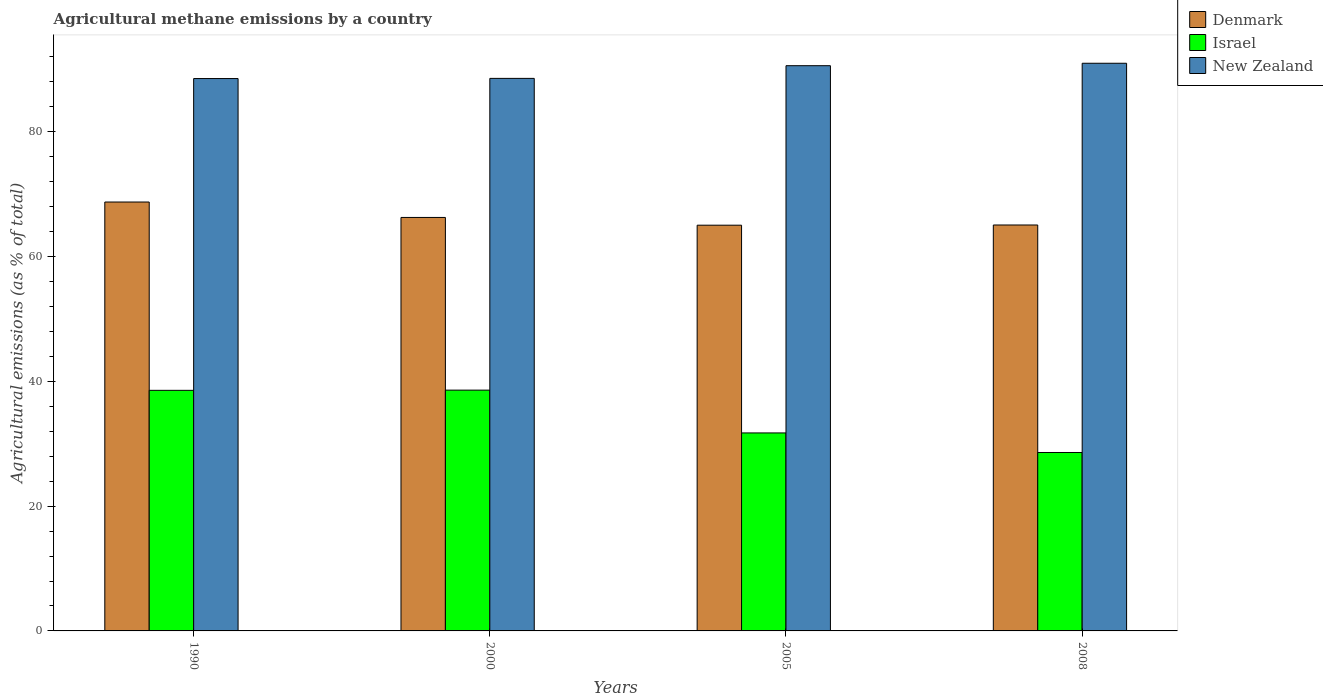How many different coloured bars are there?
Provide a short and direct response. 3. How many groups of bars are there?
Ensure brevity in your answer.  4. Are the number of bars on each tick of the X-axis equal?
Give a very brief answer. Yes. How many bars are there on the 4th tick from the left?
Ensure brevity in your answer.  3. What is the label of the 3rd group of bars from the left?
Ensure brevity in your answer.  2005. What is the amount of agricultural methane emitted in Israel in 2008?
Offer a terse response. 28.6. Across all years, what is the maximum amount of agricultural methane emitted in Israel?
Make the answer very short. 38.59. Across all years, what is the minimum amount of agricultural methane emitted in Denmark?
Ensure brevity in your answer.  65.03. In which year was the amount of agricultural methane emitted in New Zealand minimum?
Provide a short and direct response. 1990. What is the total amount of agricultural methane emitted in Denmark in the graph?
Offer a terse response. 265.11. What is the difference between the amount of agricultural methane emitted in Israel in 1990 and that in 2005?
Make the answer very short. 6.83. What is the difference between the amount of agricultural methane emitted in Denmark in 2008 and the amount of agricultural methane emitted in Israel in 1990?
Give a very brief answer. 26.5. What is the average amount of agricultural methane emitted in Israel per year?
Make the answer very short. 34.37. In the year 2005, what is the difference between the amount of agricultural methane emitted in Israel and amount of agricultural methane emitted in Denmark?
Give a very brief answer. -33.3. In how many years, is the amount of agricultural methane emitted in New Zealand greater than 52 %?
Provide a short and direct response. 4. What is the ratio of the amount of agricultural methane emitted in Israel in 2000 to that in 2008?
Give a very brief answer. 1.35. Is the amount of agricultural methane emitted in Denmark in 1990 less than that in 2000?
Your answer should be compact. No. Is the difference between the amount of agricultural methane emitted in Israel in 2000 and 2008 greater than the difference between the amount of agricultural methane emitted in Denmark in 2000 and 2008?
Provide a succinct answer. Yes. What is the difference between the highest and the second highest amount of agricultural methane emitted in Denmark?
Your answer should be very brief. 2.47. What is the difference between the highest and the lowest amount of agricultural methane emitted in Israel?
Provide a short and direct response. 10. In how many years, is the amount of agricultural methane emitted in Israel greater than the average amount of agricultural methane emitted in Israel taken over all years?
Your answer should be very brief. 2. Is the sum of the amount of agricultural methane emitted in New Zealand in 2000 and 2005 greater than the maximum amount of agricultural methane emitted in Denmark across all years?
Give a very brief answer. Yes. What does the 2nd bar from the left in 2000 represents?
Give a very brief answer. Israel. How many bars are there?
Your answer should be very brief. 12. Are all the bars in the graph horizontal?
Keep it short and to the point. No. How many years are there in the graph?
Provide a succinct answer. 4. Are the values on the major ticks of Y-axis written in scientific E-notation?
Provide a short and direct response. No. Does the graph contain grids?
Provide a succinct answer. No. Where does the legend appear in the graph?
Offer a terse response. Top right. What is the title of the graph?
Offer a terse response. Agricultural methane emissions by a country. What is the label or title of the Y-axis?
Provide a short and direct response. Agricultural emissions (as % of total). What is the Agricultural emissions (as % of total) in Denmark in 1990?
Keep it short and to the point. 68.75. What is the Agricultural emissions (as % of total) of Israel in 1990?
Provide a succinct answer. 38.56. What is the Agricultural emissions (as % of total) in New Zealand in 1990?
Your answer should be very brief. 88.54. What is the Agricultural emissions (as % of total) of Denmark in 2000?
Make the answer very short. 66.27. What is the Agricultural emissions (as % of total) of Israel in 2000?
Offer a very short reply. 38.59. What is the Agricultural emissions (as % of total) of New Zealand in 2000?
Your response must be concise. 88.56. What is the Agricultural emissions (as % of total) of Denmark in 2005?
Offer a very short reply. 65.03. What is the Agricultural emissions (as % of total) of Israel in 2005?
Provide a short and direct response. 31.73. What is the Agricultural emissions (as % of total) of New Zealand in 2005?
Ensure brevity in your answer.  90.59. What is the Agricultural emissions (as % of total) of Denmark in 2008?
Keep it short and to the point. 65.06. What is the Agricultural emissions (as % of total) in Israel in 2008?
Make the answer very short. 28.6. What is the Agricultural emissions (as % of total) of New Zealand in 2008?
Provide a short and direct response. 90.99. Across all years, what is the maximum Agricultural emissions (as % of total) of Denmark?
Provide a short and direct response. 68.75. Across all years, what is the maximum Agricultural emissions (as % of total) of Israel?
Keep it short and to the point. 38.59. Across all years, what is the maximum Agricultural emissions (as % of total) of New Zealand?
Ensure brevity in your answer.  90.99. Across all years, what is the minimum Agricultural emissions (as % of total) in Denmark?
Give a very brief answer. 65.03. Across all years, what is the minimum Agricultural emissions (as % of total) in Israel?
Make the answer very short. 28.6. Across all years, what is the minimum Agricultural emissions (as % of total) in New Zealand?
Offer a very short reply. 88.54. What is the total Agricultural emissions (as % of total) of Denmark in the graph?
Provide a succinct answer. 265.11. What is the total Agricultural emissions (as % of total) in Israel in the graph?
Provide a short and direct response. 137.49. What is the total Agricultural emissions (as % of total) in New Zealand in the graph?
Offer a terse response. 358.68. What is the difference between the Agricultural emissions (as % of total) of Denmark in 1990 and that in 2000?
Provide a short and direct response. 2.47. What is the difference between the Agricultural emissions (as % of total) in Israel in 1990 and that in 2000?
Ensure brevity in your answer.  -0.03. What is the difference between the Agricultural emissions (as % of total) of New Zealand in 1990 and that in 2000?
Offer a terse response. -0.03. What is the difference between the Agricultural emissions (as % of total) of Denmark in 1990 and that in 2005?
Ensure brevity in your answer.  3.71. What is the difference between the Agricultural emissions (as % of total) in Israel in 1990 and that in 2005?
Your answer should be compact. 6.83. What is the difference between the Agricultural emissions (as % of total) of New Zealand in 1990 and that in 2005?
Your response must be concise. -2.06. What is the difference between the Agricultural emissions (as % of total) in Denmark in 1990 and that in 2008?
Keep it short and to the point. 3.68. What is the difference between the Agricultural emissions (as % of total) in Israel in 1990 and that in 2008?
Make the answer very short. 9.96. What is the difference between the Agricultural emissions (as % of total) of New Zealand in 1990 and that in 2008?
Keep it short and to the point. -2.45. What is the difference between the Agricultural emissions (as % of total) in Denmark in 2000 and that in 2005?
Ensure brevity in your answer.  1.24. What is the difference between the Agricultural emissions (as % of total) of Israel in 2000 and that in 2005?
Give a very brief answer. 6.86. What is the difference between the Agricultural emissions (as % of total) of New Zealand in 2000 and that in 2005?
Give a very brief answer. -2.03. What is the difference between the Agricultural emissions (as % of total) of Denmark in 2000 and that in 2008?
Keep it short and to the point. 1.21. What is the difference between the Agricultural emissions (as % of total) of Israel in 2000 and that in 2008?
Provide a succinct answer. 10. What is the difference between the Agricultural emissions (as % of total) in New Zealand in 2000 and that in 2008?
Make the answer very short. -2.42. What is the difference between the Agricultural emissions (as % of total) of Denmark in 2005 and that in 2008?
Offer a terse response. -0.03. What is the difference between the Agricultural emissions (as % of total) of Israel in 2005 and that in 2008?
Ensure brevity in your answer.  3.14. What is the difference between the Agricultural emissions (as % of total) in New Zealand in 2005 and that in 2008?
Provide a short and direct response. -0.39. What is the difference between the Agricultural emissions (as % of total) of Denmark in 1990 and the Agricultural emissions (as % of total) of Israel in 2000?
Give a very brief answer. 30.15. What is the difference between the Agricultural emissions (as % of total) of Denmark in 1990 and the Agricultural emissions (as % of total) of New Zealand in 2000?
Provide a succinct answer. -19.82. What is the difference between the Agricultural emissions (as % of total) in Israel in 1990 and the Agricultural emissions (as % of total) in New Zealand in 2000?
Make the answer very short. -50. What is the difference between the Agricultural emissions (as % of total) in Denmark in 1990 and the Agricultural emissions (as % of total) in Israel in 2005?
Keep it short and to the point. 37.01. What is the difference between the Agricultural emissions (as % of total) in Denmark in 1990 and the Agricultural emissions (as % of total) in New Zealand in 2005?
Provide a succinct answer. -21.85. What is the difference between the Agricultural emissions (as % of total) in Israel in 1990 and the Agricultural emissions (as % of total) in New Zealand in 2005?
Your answer should be compact. -52.03. What is the difference between the Agricultural emissions (as % of total) in Denmark in 1990 and the Agricultural emissions (as % of total) in Israel in 2008?
Your answer should be very brief. 40.15. What is the difference between the Agricultural emissions (as % of total) of Denmark in 1990 and the Agricultural emissions (as % of total) of New Zealand in 2008?
Keep it short and to the point. -22.24. What is the difference between the Agricultural emissions (as % of total) of Israel in 1990 and the Agricultural emissions (as % of total) of New Zealand in 2008?
Offer a very short reply. -52.42. What is the difference between the Agricultural emissions (as % of total) of Denmark in 2000 and the Agricultural emissions (as % of total) of Israel in 2005?
Keep it short and to the point. 34.54. What is the difference between the Agricultural emissions (as % of total) of Denmark in 2000 and the Agricultural emissions (as % of total) of New Zealand in 2005?
Provide a short and direct response. -24.32. What is the difference between the Agricultural emissions (as % of total) of Israel in 2000 and the Agricultural emissions (as % of total) of New Zealand in 2005?
Your answer should be very brief. -52. What is the difference between the Agricultural emissions (as % of total) in Denmark in 2000 and the Agricultural emissions (as % of total) in Israel in 2008?
Provide a succinct answer. 37.67. What is the difference between the Agricultural emissions (as % of total) of Denmark in 2000 and the Agricultural emissions (as % of total) of New Zealand in 2008?
Your answer should be compact. -24.71. What is the difference between the Agricultural emissions (as % of total) in Israel in 2000 and the Agricultural emissions (as % of total) in New Zealand in 2008?
Provide a succinct answer. -52.39. What is the difference between the Agricultural emissions (as % of total) of Denmark in 2005 and the Agricultural emissions (as % of total) of Israel in 2008?
Give a very brief answer. 36.43. What is the difference between the Agricultural emissions (as % of total) in Denmark in 2005 and the Agricultural emissions (as % of total) in New Zealand in 2008?
Keep it short and to the point. -25.96. What is the difference between the Agricultural emissions (as % of total) in Israel in 2005 and the Agricultural emissions (as % of total) in New Zealand in 2008?
Your answer should be compact. -59.25. What is the average Agricultural emissions (as % of total) in Denmark per year?
Offer a very short reply. 66.28. What is the average Agricultural emissions (as % of total) of Israel per year?
Ensure brevity in your answer.  34.37. What is the average Agricultural emissions (as % of total) of New Zealand per year?
Keep it short and to the point. 89.67. In the year 1990, what is the difference between the Agricultural emissions (as % of total) in Denmark and Agricultural emissions (as % of total) in Israel?
Provide a short and direct response. 30.18. In the year 1990, what is the difference between the Agricultural emissions (as % of total) in Denmark and Agricultural emissions (as % of total) in New Zealand?
Offer a terse response. -19.79. In the year 1990, what is the difference between the Agricultural emissions (as % of total) in Israel and Agricultural emissions (as % of total) in New Zealand?
Provide a short and direct response. -49.97. In the year 2000, what is the difference between the Agricultural emissions (as % of total) of Denmark and Agricultural emissions (as % of total) of Israel?
Make the answer very short. 27.68. In the year 2000, what is the difference between the Agricultural emissions (as % of total) in Denmark and Agricultural emissions (as % of total) in New Zealand?
Provide a succinct answer. -22.29. In the year 2000, what is the difference between the Agricultural emissions (as % of total) in Israel and Agricultural emissions (as % of total) in New Zealand?
Keep it short and to the point. -49.97. In the year 2005, what is the difference between the Agricultural emissions (as % of total) in Denmark and Agricultural emissions (as % of total) in Israel?
Ensure brevity in your answer.  33.3. In the year 2005, what is the difference between the Agricultural emissions (as % of total) in Denmark and Agricultural emissions (as % of total) in New Zealand?
Ensure brevity in your answer.  -25.56. In the year 2005, what is the difference between the Agricultural emissions (as % of total) in Israel and Agricultural emissions (as % of total) in New Zealand?
Provide a short and direct response. -58.86. In the year 2008, what is the difference between the Agricultural emissions (as % of total) of Denmark and Agricultural emissions (as % of total) of Israel?
Give a very brief answer. 36.47. In the year 2008, what is the difference between the Agricultural emissions (as % of total) of Denmark and Agricultural emissions (as % of total) of New Zealand?
Your response must be concise. -25.92. In the year 2008, what is the difference between the Agricultural emissions (as % of total) in Israel and Agricultural emissions (as % of total) in New Zealand?
Make the answer very short. -62.39. What is the ratio of the Agricultural emissions (as % of total) of Denmark in 1990 to that in 2000?
Your answer should be compact. 1.04. What is the ratio of the Agricultural emissions (as % of total) in Israel in 1990 to that in 2000?
Ensure brevity in your answer.  1. What is the ratio of the Agricultural emissions (as % of total) in Denmark in 1990 to that in 2005?
Keep it short and to the point. 1.06. What is the ratio of the Agricultural emissions (as % of total) of Israel in 1990 to that in 2005?
Offer a very short reply. 1.22. What is the ratio of the Agricultural emissions (as % of total) of New Zealand in 1990 to that in 2005?
Provide a short and direct response. 0.98. What is the ratio of the Agricultural emissions (as % of total) of Denmark in 1990 to that in 2008?
Your answer should be compact. 1.06. What is the ratio of the Agricultural emissions (as % of total) in Israel in 1990 to that in 2008?
Your answer should be compact. 1.35. What is the ratio of the Agricultural emissions (as % of total) of New Zealand in 1990 to that in 2008?
Your response must be concise. 0.97. What is the ratio of the Agricultural emissions (as % of total) in Denmark in 2000 to that in 2005?
Provide a succinct answer. 1.02. What is the ratio of the Agricultural emissions (as % of total) of Israel in 2000 to that in 2005?
Your answer should be very brief. 1.22. What is the ratio of the Agricultural emissions (as % of total) of New Zealand in 2000 to that in 2005?
Offer a terse response. 0.98. What is the ratio of the Agricultural emissions (as % of total) in Denmark in 2000 to that in 2008?
Offer a terse response. 1.02. What is the ratio of the Agricultural emissions (as % of total) in Israel in 2000 to that in 2008?
Give a very brief answer. 1.35. What is the ratio of the Agricultural emissions (as % of total) of New Zealand in 2000 to that in 2008?
Your response must be concise. 0.97. What is the ratio of the Agricultural emissions (as % of total) in Denmark in 2005 to that in 2008?
Your answer should be compact. 1. What is the ratio of the Agricultural emissions (as % of total) of Israel in 2005 to that in 2008?
Give a very brief answer. 1.11. What is the ratio of the Agricultural emissions (as % of total) of New Zealand in 2005 to that in 2008?
Offer a very short reply. 1. What is the difference between the highest and the second highest Agricultural emissions (as % of total) of Denmark?
Provide a succinct answer. 2.47. What is the difference between the highest and the second highest Agricultural emissions (as % of total) of Israel?
Ensure brevity in your answer.  0.03. What is the difference between the highest and the second highest Agricultural emissions (as % of total) in New Zealand?
Give a very brief answer. 0.39. What is the difference between the highest and the lowest Agricultural emissions (as % of total) of Denmark?
Offer a terse response. 3.71. What is the difference between the highest and the lowest Agricultural emissions (as % of total) of Israel?
Your answer should be compact. 10. What is the difference between the highest and the lowest Agricultural emissions (as % of total) of New Zealand?
Your answer should be very brief. 2.45. 